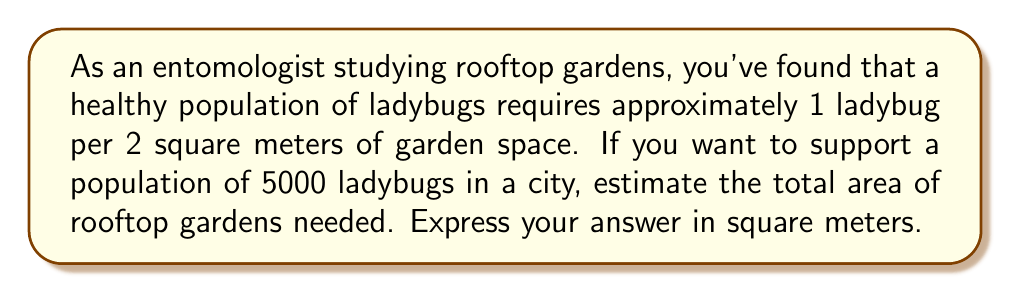Show me your answer to this math problem. To solve this problem, we need to follow these steps:

1. Understand the given information:
   * 1 ladybug requires 2 square meters of garden space
   * We want to support 5000 ladybugs

2. Set up the equation:
   Let $x$ be the total area of rooftop gardens needed in square meters.
   
   $$\frac{1 \text{ ladybug}}{2 \text{ m}^2} = \frac{5000 \text{ ladybugs}}{x \text{ m}^2}$$

3. Cross multiply:
   $$1 \cdot x = 2 \cdot 5000$$

4. Solve for $x$:
   $$x = 2 \cdot 5000 = 10000$$

Therefore, the total area of rooftop gardens needed to support 5000 ladybugs is 10000 square meters.
Answer: $10000 \text{ m}^2$ 